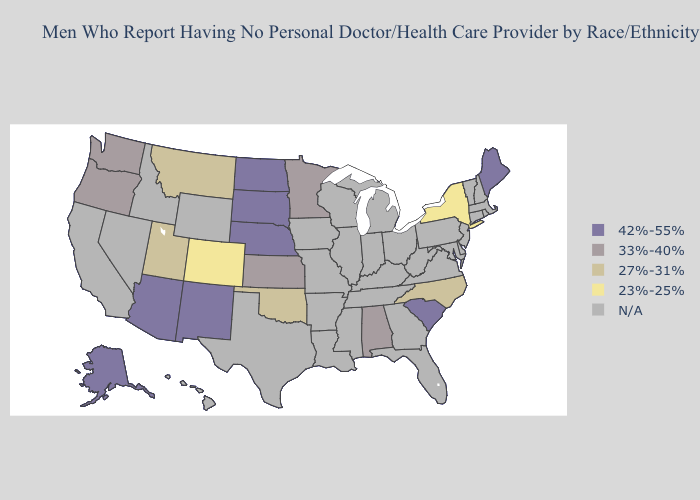What is the value of Washington?
Keep it brief. 33%-40%. What is the lowest value in the Northeast?
Answer briefly. 23%-25%. Name the states that have a value in the range 42%-55%?
Short answer required. Alaska, Arizona, Maine, Nebraska, New Mexico, North Dakota, South Carolina, South Dakota. What is the highest value in states that border New Jersey?
Concise answer only. 23%-25%. What is the value of Maryland?
Write a very short answer. N/A. What is the value of Hawaii?
Keep it brief. N/A. Among the states that border Arizona , which have the highest value?
Short answer required. New Mexico. Does Colorado have the lowest value in the West?
Keep it brief. Yes. What is the value of Minnesota?
Concise answer only. 33%-40%. Which states have the lowest value in the South?
Write a very short answer. North Carolina, Oklahoma. Name the states that have a value in the range 33%-40%?
Quick response, please. Alabama, Kansas, Minnesota, Oregon, Washington. Which states have the highest value in the USA?
Keep it brief. Alaska, Arizona, Maine, Nebraska, New Mexico, North Dakota, South Carolina, South Dakota. What is the value of Iowa?
Short answer required. N/A. Which states hav the highest value in the West?
Short answer required. Alaska, Arizona, New Mexico. 